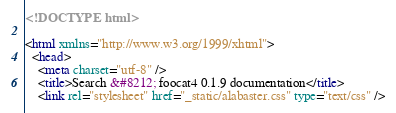Convert code to text. <code><loc_0><loc_0><loc_500><loc_500><_HTML_>
<!DOCTYPE html>

<html xmlns="http://www.w3.org/1999/xhtml">
  <head>
    <meta charset="utf-8" />
    <title>Search &#8212; foocat4 0.1.9 documentation</title>
    <link rel="stylesheet" href="_static/alabaster.css" type="text/css" /></code> 